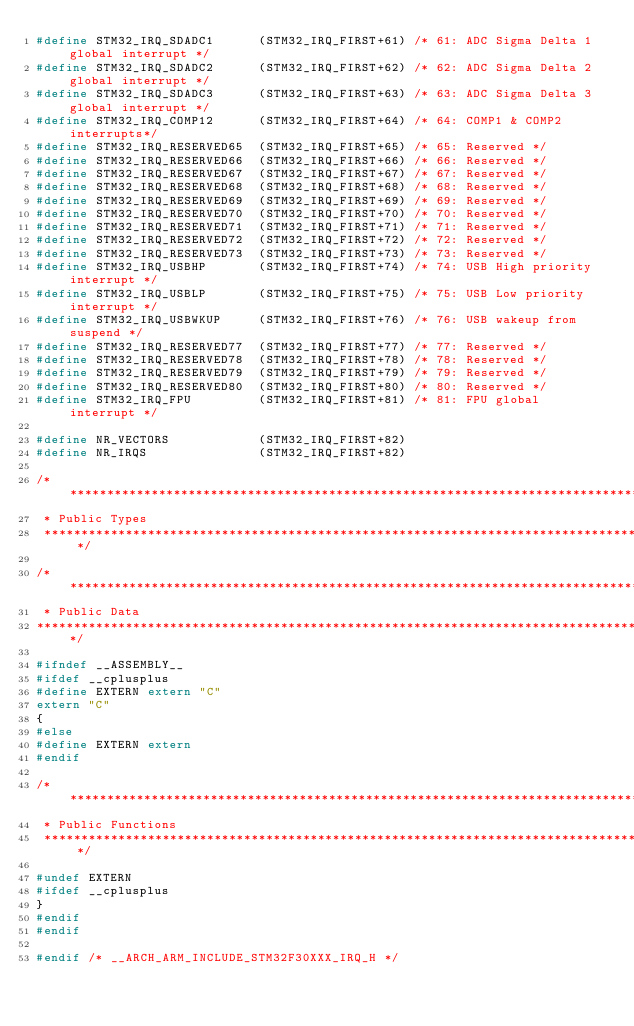<code> <loc_0><loc_0><loc_500><loc_500><_C_>#define STM32_IRQ_SDADC1      (STM32_IRQ_FIRST+61) /* 61: ADC Sigma Delta 1 global interrupt */
#define STM32_IRQ_SDADC2      (STM32_IRQ_FIRST+62) /* 62: ADC Sigma Delta 2 global interrupt */
#define STM32_IRQ_SDADC3      (STM32_IRQ_FIRST+63) /* 63: ADC Sigma Delta 3 global interrupt */
#define STM32_IRQ_COMP12      (STM32_IRQ_FIRST+64) /* 64: COMP1 & COMP2 interrupts*/
#define STM32_IRQ_RESERVED65  (STM32_IRQ_FIRST+65) /* 65: Reserved */
#define STM32_IRQ_RESERVED66  (STM32_IRQ_FIRST+66) /* 66: Reserved */
#define STM32_IRQ_RESERVED67  (STM32_IRQ_FIRST+67) /* 67: Reserved */
#define STM32_IRQ_RESERVED68  (STM32_IRQ_FIRST+68) /* 68: Reserved */
#define STM32_IRQ_RESERVED69  (STM32_IRQ_FIRST+69) /* 69: Reserved */
#define STM32_IRQ_RESERVED70  (STM32_IRQ_FIRST+70) /* 70: Reserved */
#define STM32_IRQ_RESERVED71  (STM32_IRQ_FIRST+71) /* 71: Reserved */
#define STM32_IRQ_RESERVED72  (STM32_IRQ_FIRST+72) /* 72: Reserved */
#define STM32_IRQ_RESERVED73  (STM32_IRQ_FIRST+73) /* 73: Reserved */
#define STM32_IRQ_USBHP       (STM32_IRQ_FIRST+74) /* 74: USB High priority interrupt */
#define STM32_IRQ_USBLP       (STM32_IRQ_FIRST+75) /* 75: USB Low priority interrupt */
#define STM32_IRQ_USBWKUP     (STM32_IRQ_FIRST+76) /* 76: USB wakeup from suspend */
#define STM32_IRQ_RESERVED77  (STM32_IRQ_FIRST+77) /* 77: Reserved */
#define STM32_IRQ_RESERVED78  (STM32_IRQ_FIRST+78) /* 78: Reserved */
#define STM32_IRQ_RESERVED79  (STM32_IRQ_FIRST+79) /* 79: Reserved */
#define STM32_IRQ_RESERVED80  (STM32_IRQ_FIRST+80) /* 80: Reserved */
#define STM32_IRQ_FPU         (STM32_IRQ_FIRST+81) /* 81: FPU global interrupt */

#define NR_VECTORS            (STM32_IRQ_FIRST+82)
#define NR_IRQS               (STM32_IRQ_FIRST+82)

/****************************************************************************************************
 * Public Types
 ****************************************************************************************************/

/****************************************************************************************************
 * Public Data
****************************************************************************************************/

#ifndef __ASSEMBLY__
#ifdef __cplusplus
#define EXTERN extern "C"
extern "C"
{
#else
#define EXTERN extern
#endif

/****************************************************************************************************
 * Public Functions
 ****************************************************************************************************/

#undef EXTERN
#ifdef __cplusplus
}
#endif
#endif

#endif /* __ARCH_ARM_INCLUDE_STM32F30XXX_IRQ_H */

</code> 